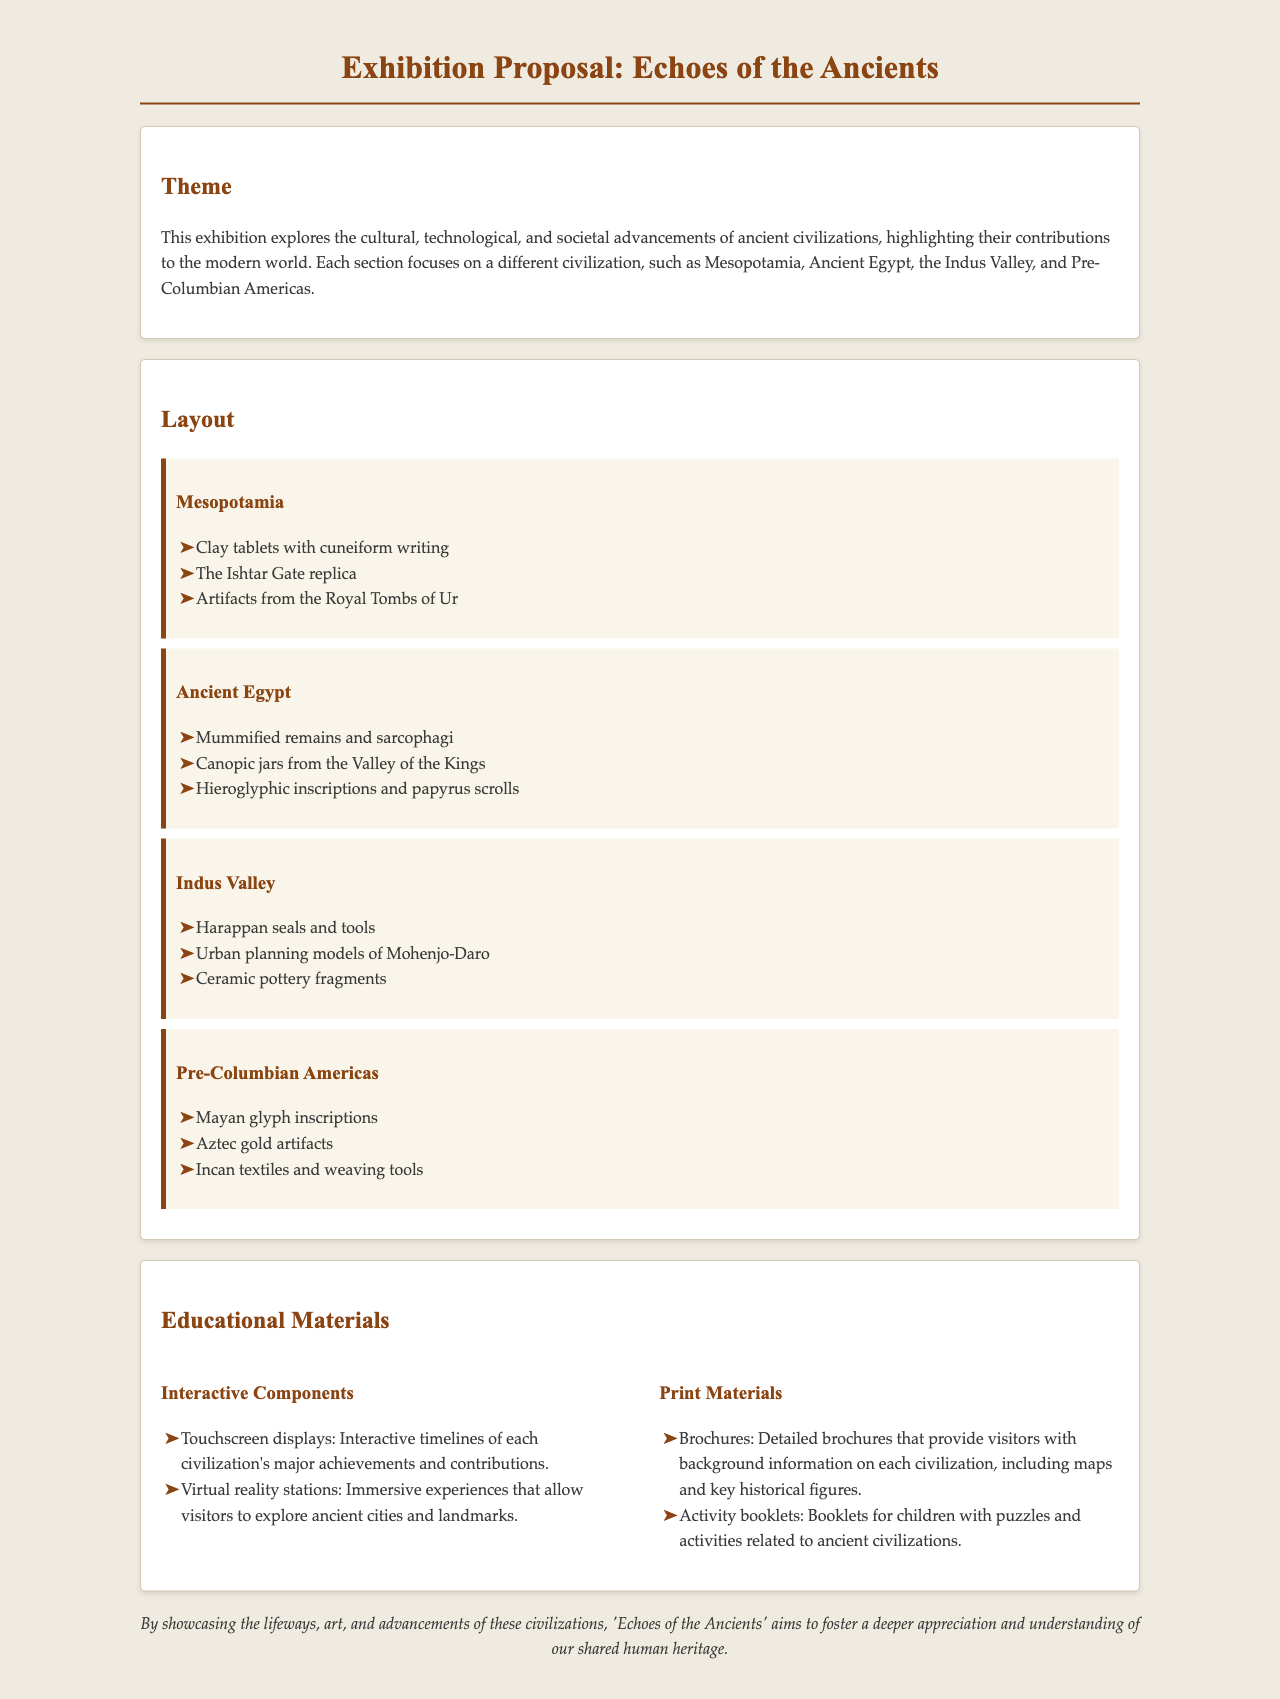What is the title of the exhibition proposal? The title of the exhibition proposal is stated at the top of the document.
Answer: Echoes of the Ancients Which civilizations are highlighted in the layout section? The civilizations listed in the layout section of the document are explicitly mentioned under their respective headings.
Answer: Mesopotamia, Ancient Egypt, Indus Valley, Pre-Columbian Americas What type of interactive component is mentioned for the educational materials? The document lists specific interactive components under the educational materials section, detailing their types.
Answer: Touchscreen displays How many civilizations are described in the layout section? The total number of civilizations can be counted by analyzing the layout section heading.
Answer: 4 What is one of the print materials included in the educational resources? The document specifies print materials under the educational materials section, providing examples.
Answer: Brochures What is the main goal of the exhibition according to the conclusion? The main goal is summarized in the conclusion, focusing on the purpose of the exhibition.
Answer: Foster appreciation and understanding Name one artifact from the Ancient Egypt section. The artifacts listed under the Ancient Egypt section are clearly outlined, allowing for specific identification.
Answer: Mummified remains What type of booklets are provided for children? The document details the educational materials section which includes specific types of resources aimed at children.
Answer: Activity booklets 